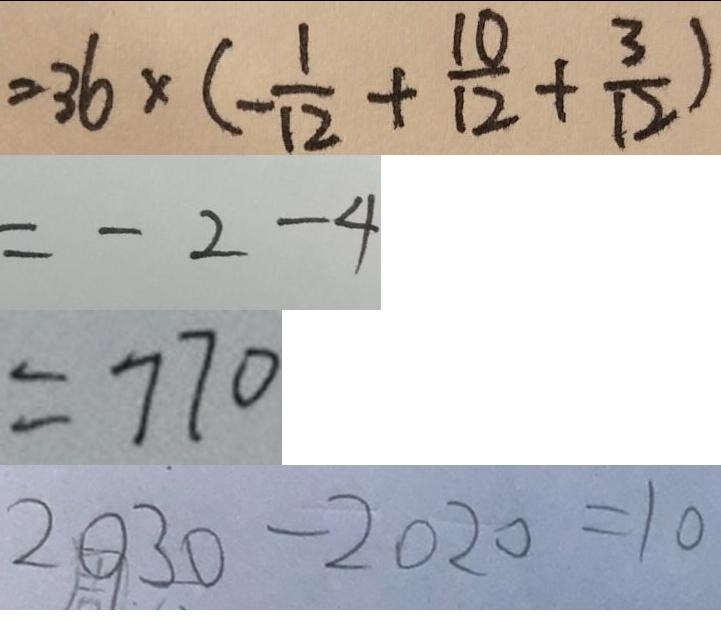<formula> <loc_0><loc_0><loc_500><loc_500>= 3 6 \times ( - \frac { 1 } { 1 2 } + \frac { 1 0 } { 1 2 } + \frac { 3 } { 1 2 } ) 
 = - 2 - 4 
 = 7 7 0 
 2 0 3 0 - 2 0 2 0 = 1 0</formula> 